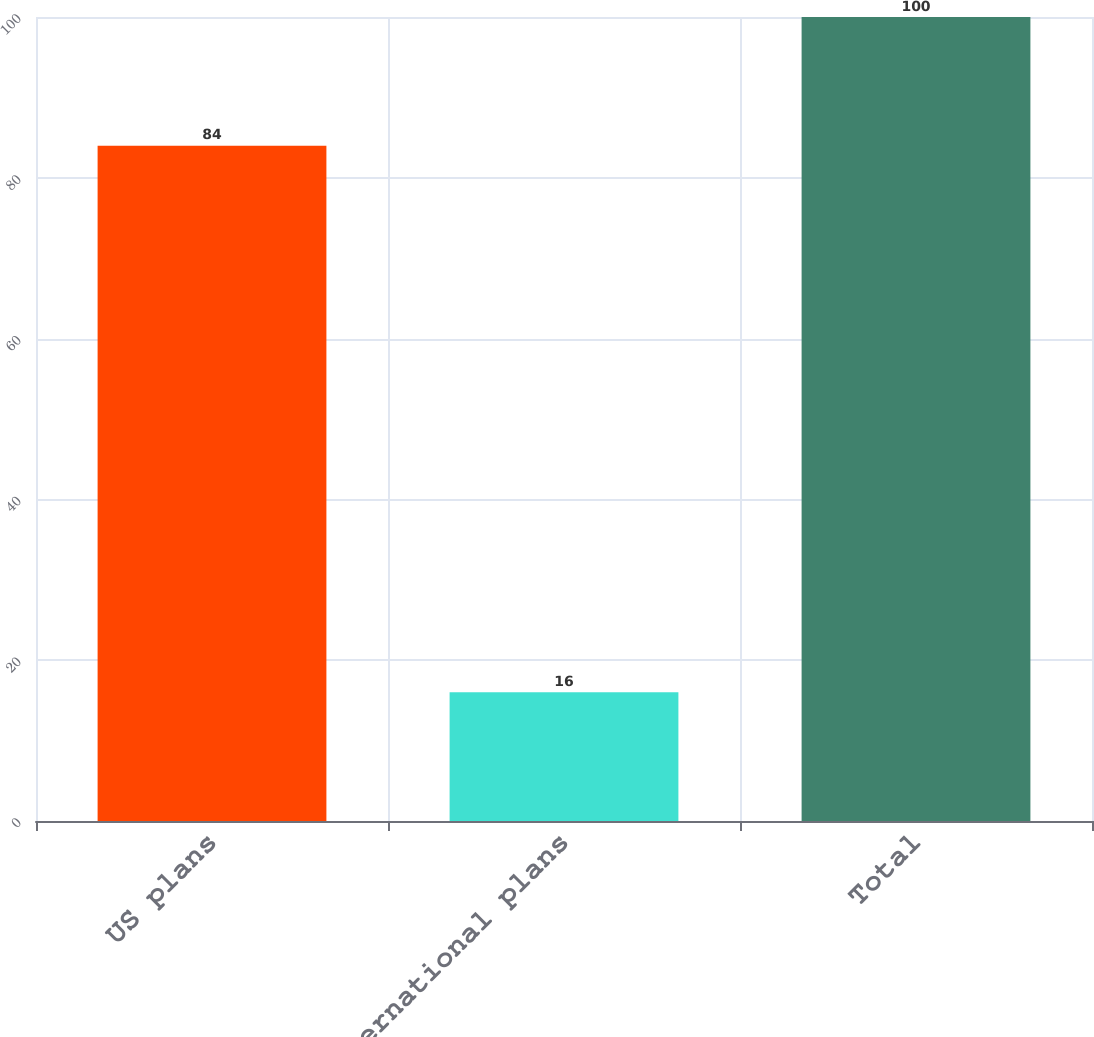Convert chart to OTSL. <chart><loc_0><loc_0><loc_500><loc_500><bar_chart><fcel>US plans<fcel>International plans<fcel>Total<nl><fcel>84<fcel>16<fcel>100<nl></chart> 